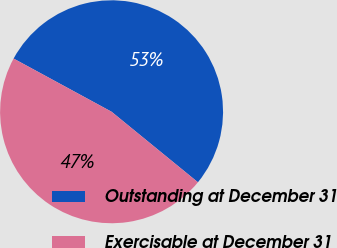Convert chart. <chart><loc_0><loc_0><loc_500><loc_500><pie_chart><fcel>Outstanding at December 31<fcel>Exercisable at December 31<nl><fcel>52.98%<fcel>47.02%<nl></chart> 